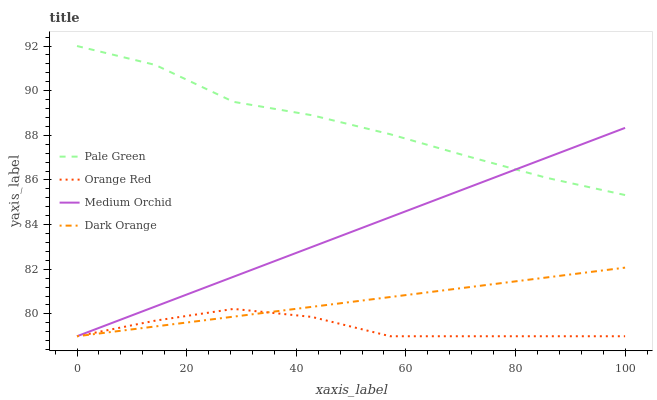Does Orange Red have the minimum area under the curve?
Answer yes or no. Yes. Does Pale Green have the maximum area under the curve?
Answer yes or no. Yes. Does Medium Orchid have the minimum area under the curve?
Answer yes or no. No. Does Medium Orchid have the maximum area under the curve?
Answer yes or no. No. Is Medium Orchid the smoothest?
Answer yes or no. Yes. Is Pale Green the roughest?
Answer yes or no. Yes. Is Pale Green the smoothest?
Answer yes or no. No. Is Medium Orchid the roughest?
Answer yes or no. No. Does Pale Green have the lowest value?
Answer yes or no. No. Does Medium Orchid have the highest value?
Answer yes or no. No. Is Orange Red less than Pale Green?
Answer yes or no. Yes. Is Pale Green greater than Orange Red?
Answer yes or no. Yes. Does Orange Red intersect Pale Green?
Answer yes or no. No. 